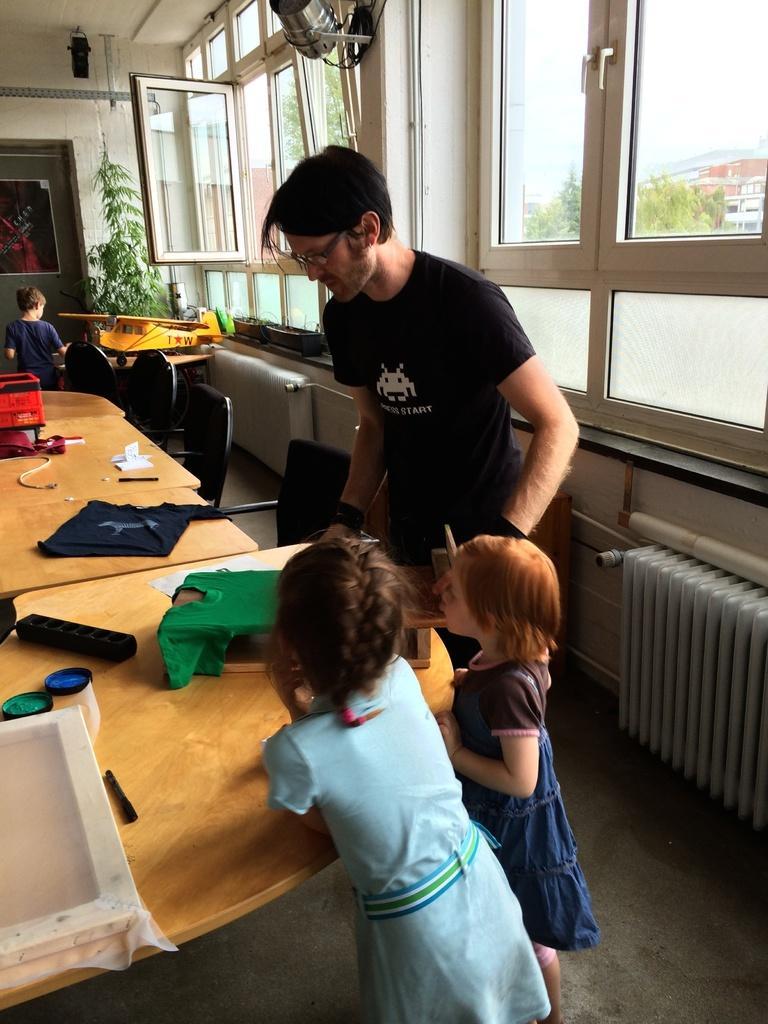Could you give a brief overview of what you see in this image? As we can see in the image there is a window, plant, wall and few people here and there and there is a table. On table there is a cloth. 